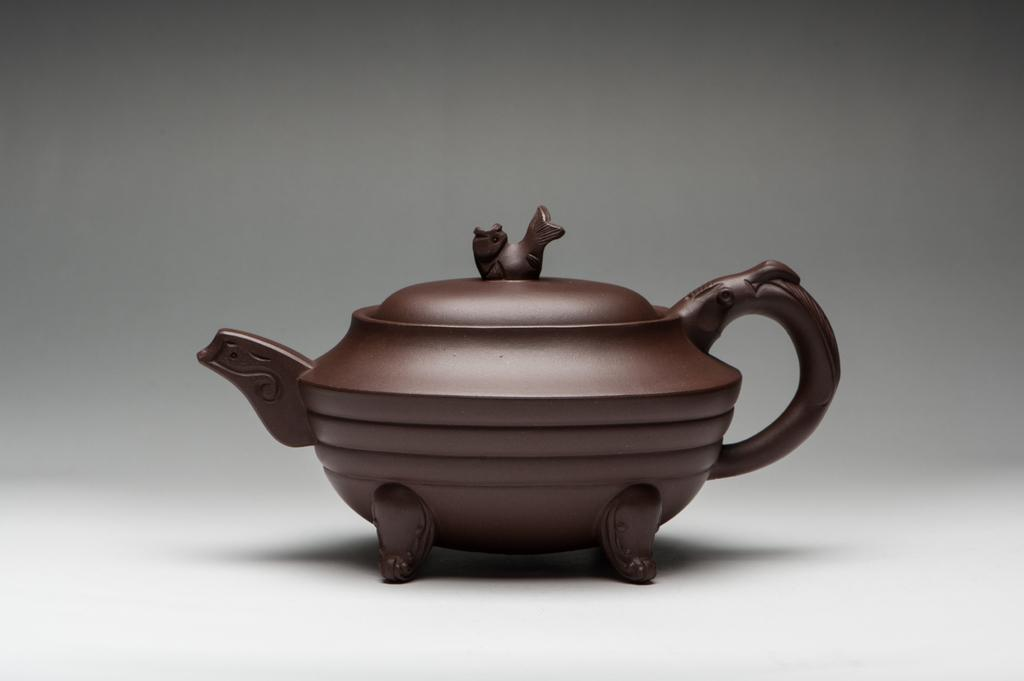What is the main object in the image? There is a teapot in the image. What color is the background of the image? The remaining portion of the image is in white color. Where is the hose located in the image? There is no hose present in the image. Is there a jail visible in the image? There is no jail present in the image. 